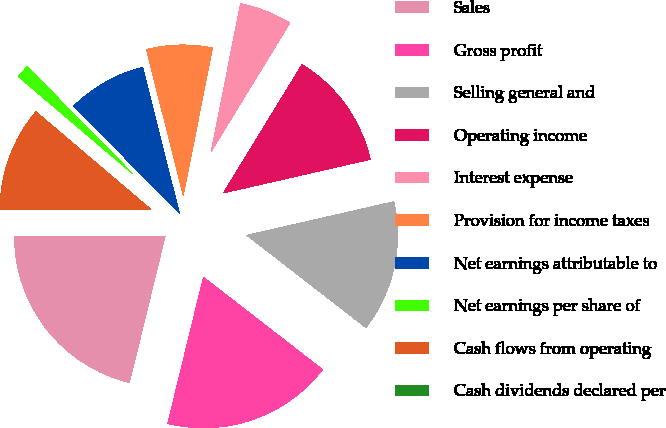<chart> <loc_0><loc_0><loc_500><loc_500><pie_chart><fcel>Sales<fcel>Gross profit<fcel>Selling general and<fcel>Operating income<fcel>Interest expense<fcel>Provision for income taxes<fcel>Net earnings attributable to<fcel>Net earnings per share of<fcel>Cash flows from operating<fcel>Cash dividends declared per<nl><fcel>21.13%<fcel>18.31%<fcel>14.08%<fcel>12.68%<fcel>5.63%<fcel>7.04%<fcel>8.45%<fcel>1.41%<fcel>11.27%<fcel>0.0%<nl></chart> 